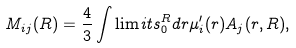Convert formula to latex. <formula><loc_0><loc_0><loc_500><loc_500>M _ { i j } ( R ) = \frac { 4 } { 3 } \int \lim i t s _ { 0 } ^ { R } d r \mu _ { i } ^ { \prime } ( r ) A _ { j } ( r , R ) ,</formula> 